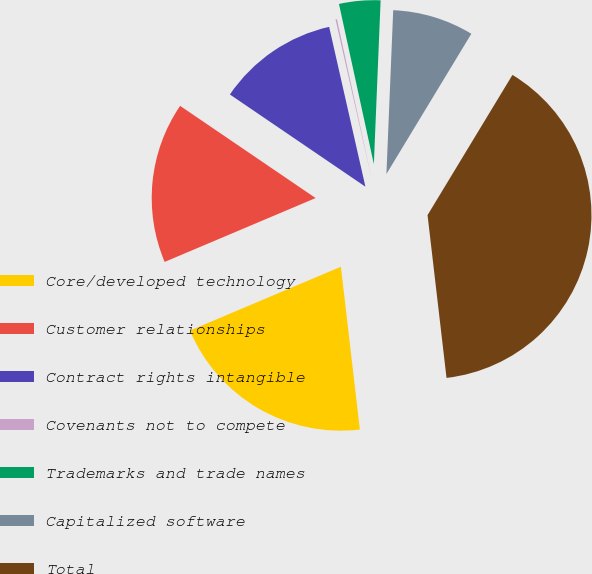<chart> <loc_0><loc_0><loc_500><loc_500><pie_chart><fcel>Core/developed technology<fcel>Customer relationships<fcel>Contract rights intangible<fcel>Covenants not to compete<fcel>Trademarks and trade names<fcel>Capitalized software<fcel>Total<nl><fcel>20.48%<fcel>15.88%<fcel>11.94%<fcel>0.14%<fcel>4.07%<fcel>8.01%<fcel>39.49%<nl></chart> 